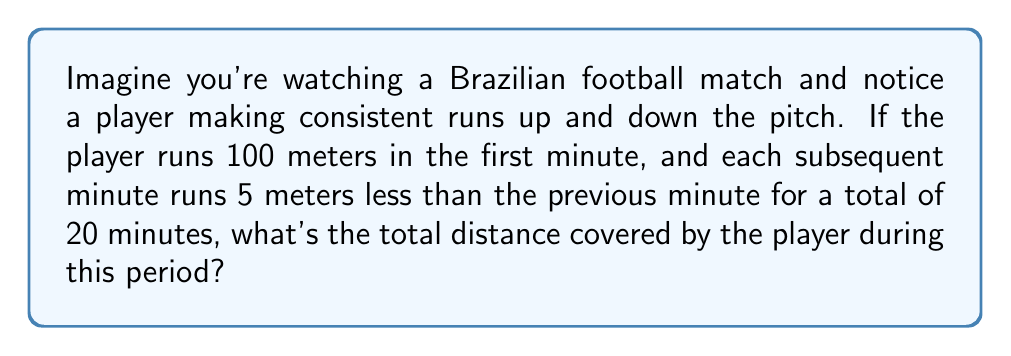Teach me how to tackle this problem. Let's approach this step-by-step using an arithmetic sequence:

1) The sequence of distances run each minute forms an arithmetic sequence with:
   First term, $a_1 = 100$ meters
   Common difference, $d = -5$ meters
   Number of terms, $n = 20$ minutes

2) The last term of the sequence can be calculated using:
   $a_n = a_1 + (n-1)d$
   $a_{20} = 100 + (20-1)(-5) = 100 - 95 = 5$ meters

3) For an arithmetic sequence, the sum of terms is given by:
   $S_n = \frac{n}{2}(a_1 + a_n)$

4) Substituting our values:
   $S_{20} = \frac{20}{2}(100 + 5)$
   $S_{20} = 10(105)$
   $S_{20} = 1050$ meters

Therefore, the total distance covered by the player is 1050 meters.
Answer: 1050 meters 